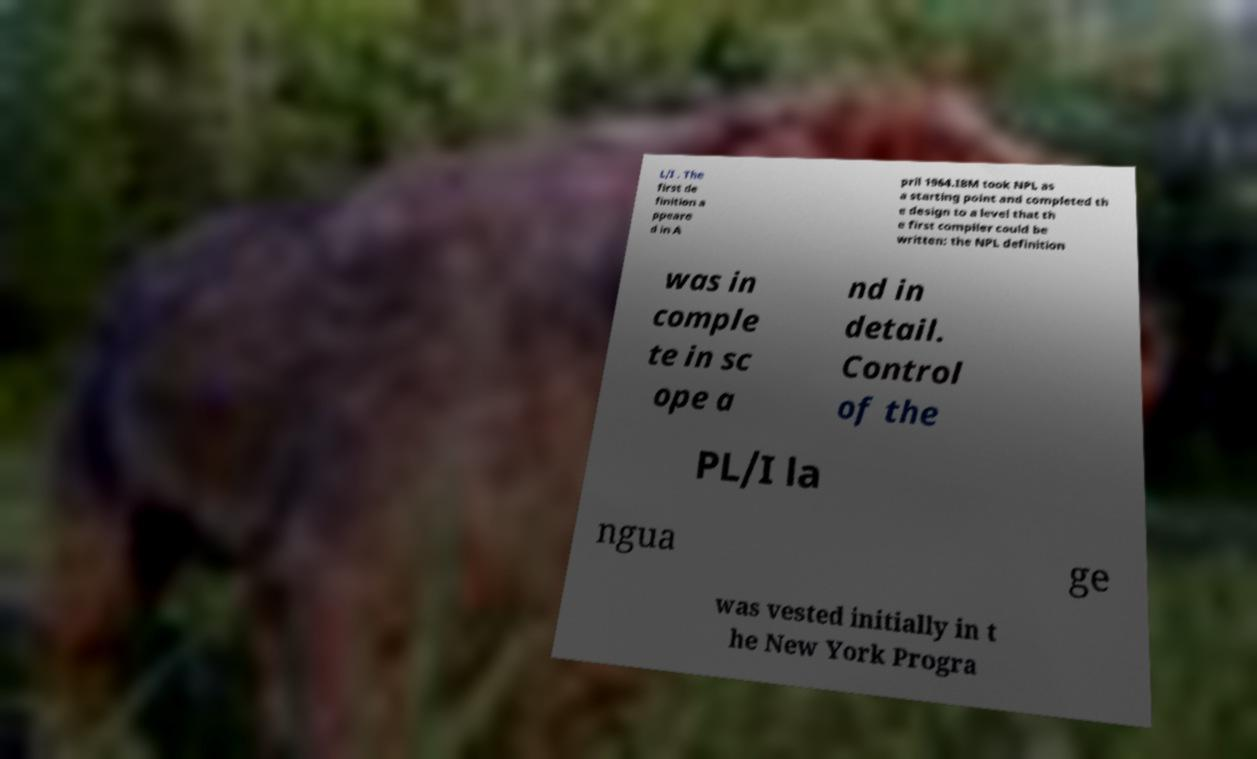Could you assist in decoding the text presented in this image and type it out clearly? L/I . The first de finition a ppeare d in A pril 1964.IBM took NPL as a starting point and completed th e design to a level that th e first compiler could be written: the NPL definition was in comple te in sc ope a nd in detail. Control of the PL/I la ngua ge was vested initially in t he New York Progra 